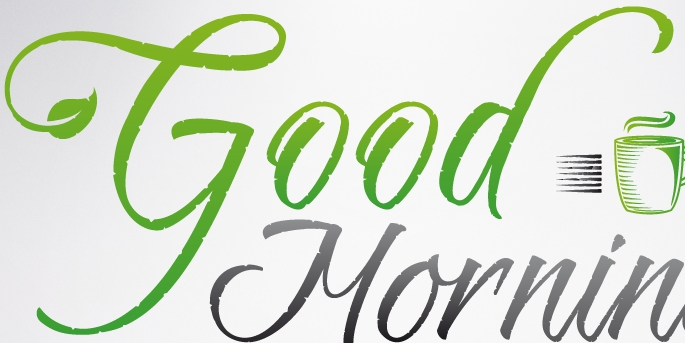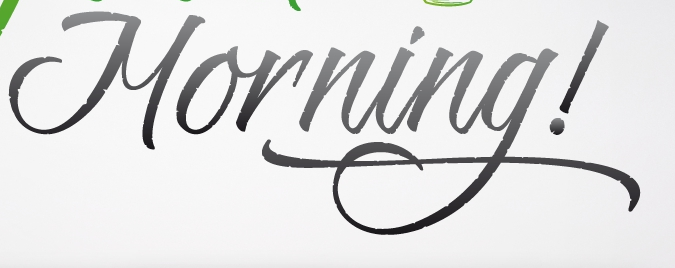What words can you see in these images in sequence, separated by a semicolon? Good; Morning! 